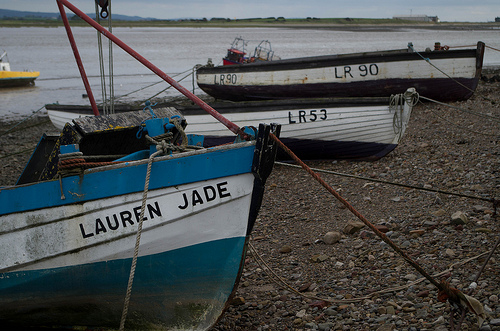Describe the weather conditions implied by the image. The overcast sky and absence of people suggest a gloomy or chilly day. The calmness of the nearby water and the fact that the boats are dry and moored on land hint at low tide conditions, possibly in anticipation of inclement weather or it being a routine mooring spot. 